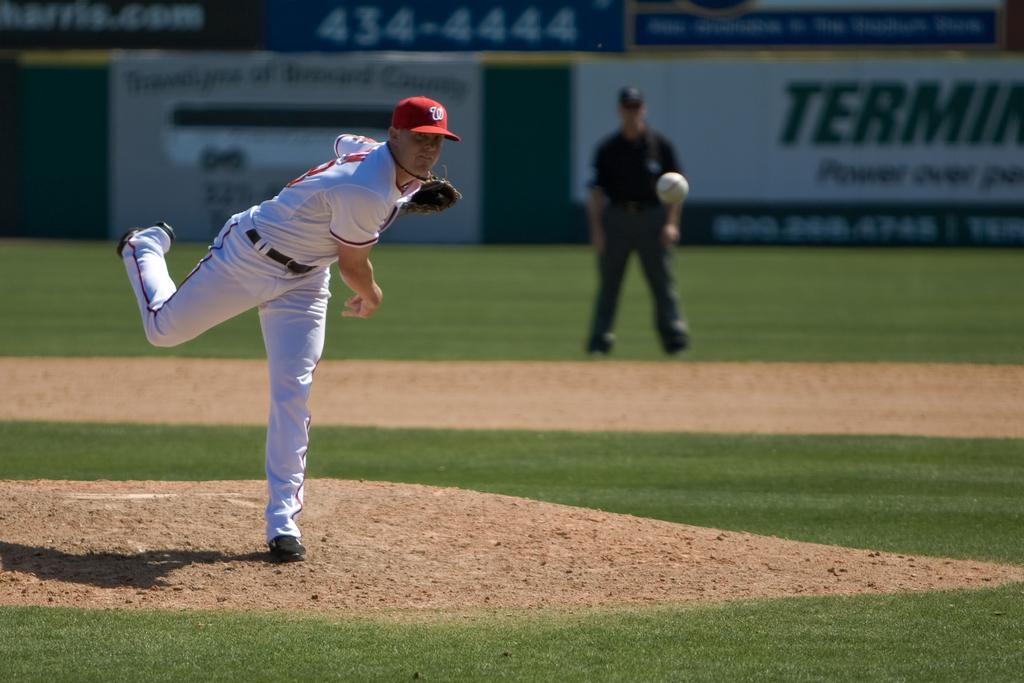<image>
Create a compact narrative representing the image presented. The baseball pitcher has a W logo on his cap. 